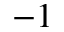<formula> <loc_0><loc_0><loc_500><loc_500>^ { - 1 }</formula> 